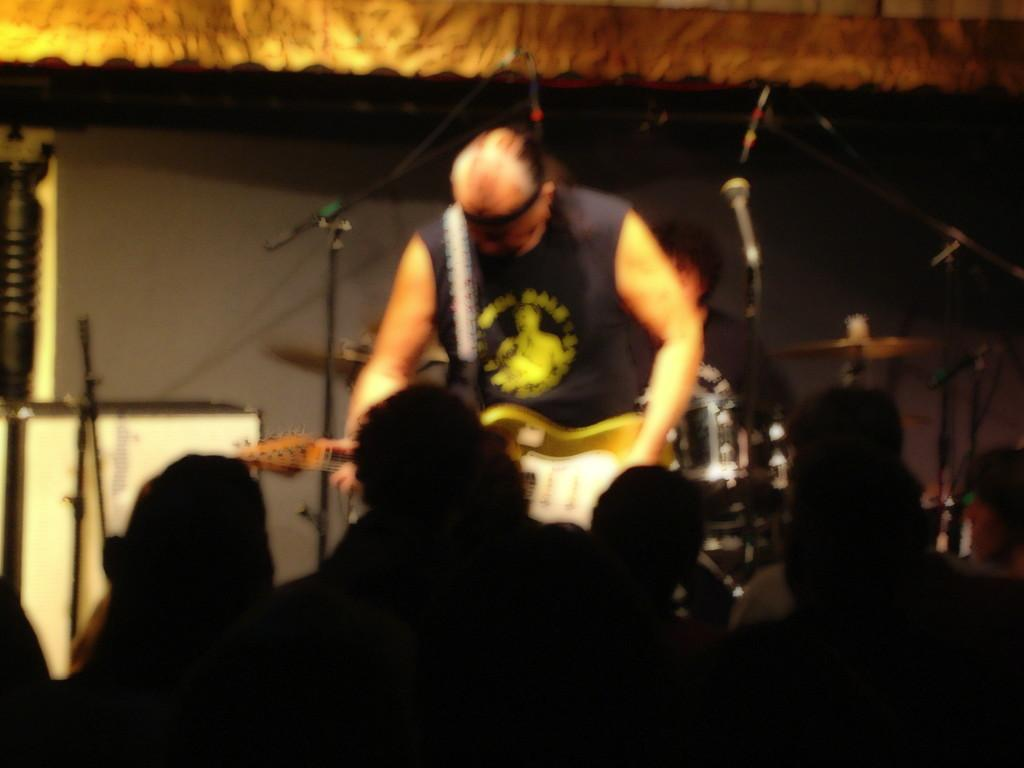What is the person in the image doing? The person in the image is standing and playing the guitar. What object is present for amplifying the person's voice? There is a microphone in the image. Is there any support for the microphone? Yes, there is a stand for the microphone in the image. How many people are present in the image besides the person playing the guitar? There is a group of persons standing in the image. What type of meat is being served to the company in the image? There is no mention of meat or a company in the image; it features a person playing the guitar, a microphone, its stand, and a group of persons standing. 